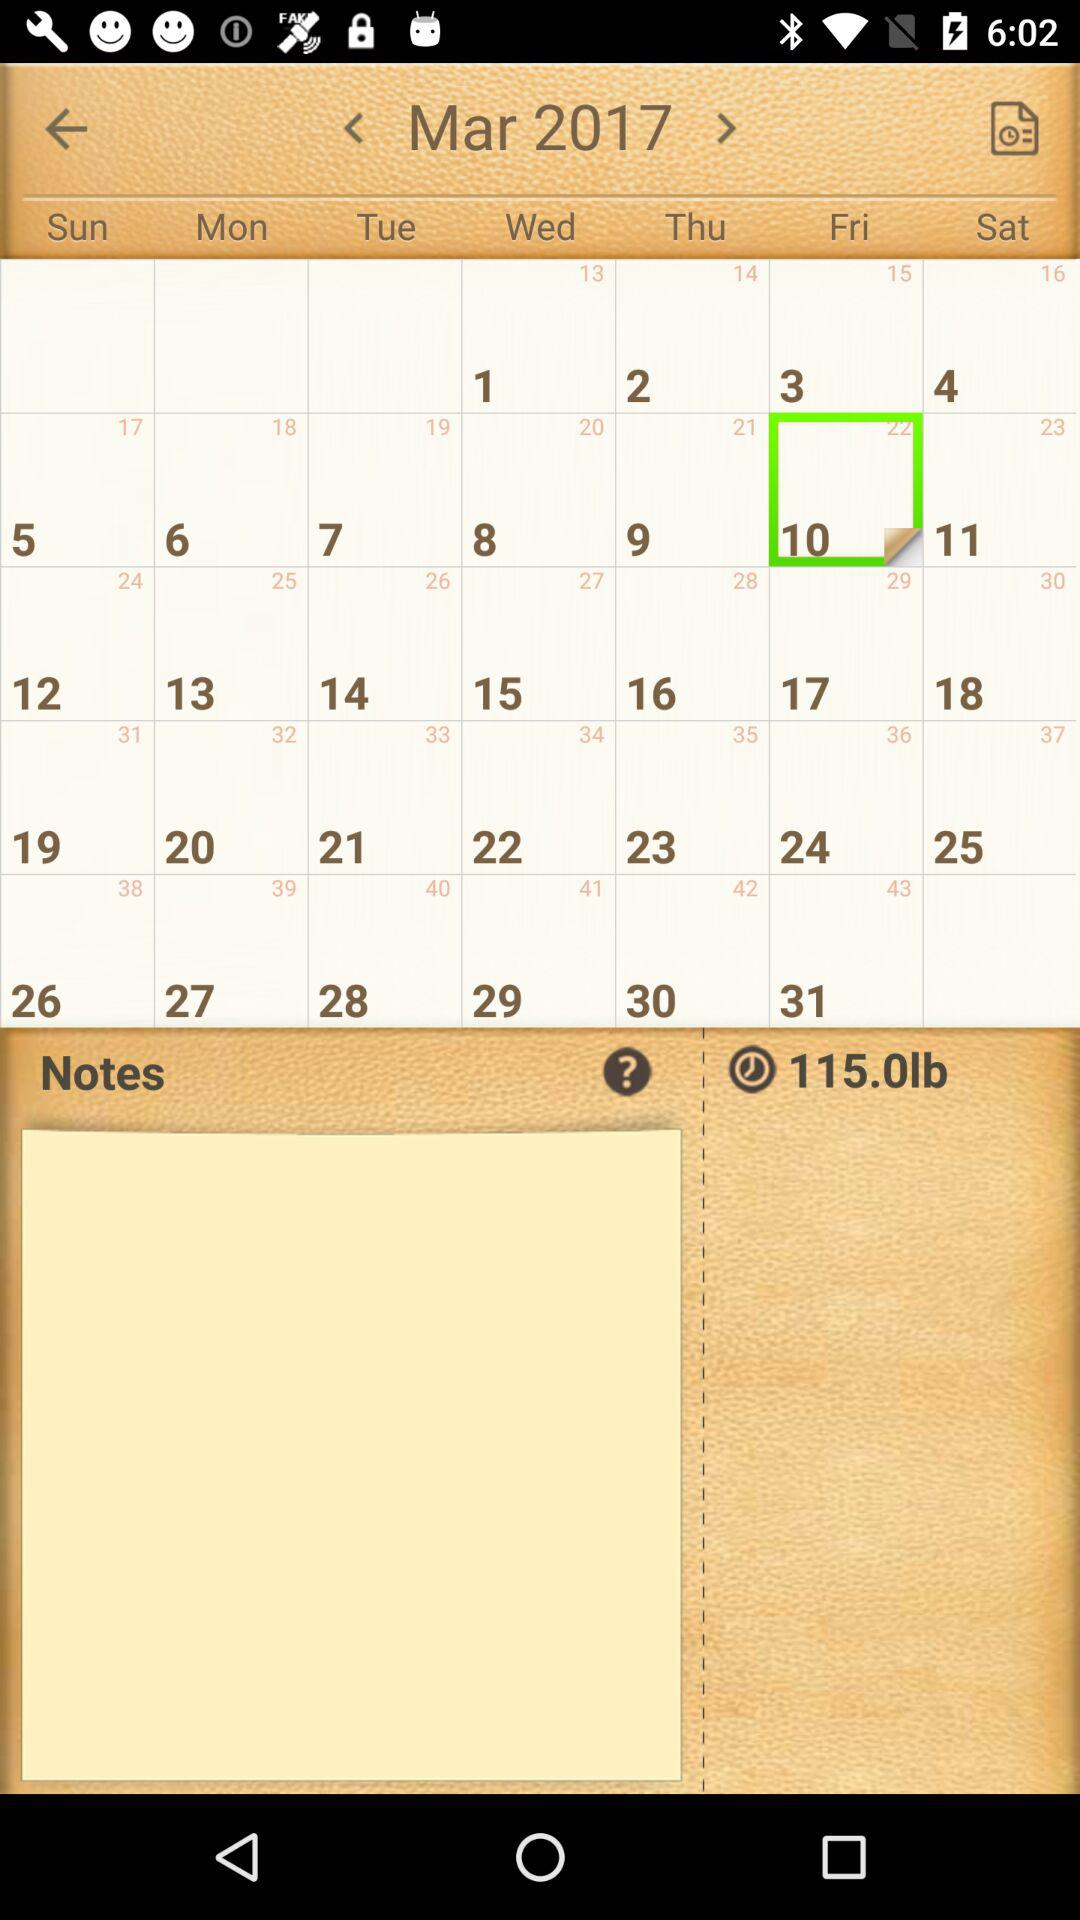What is the month and year shown on the calendar? The month is March and the year is 2017. 